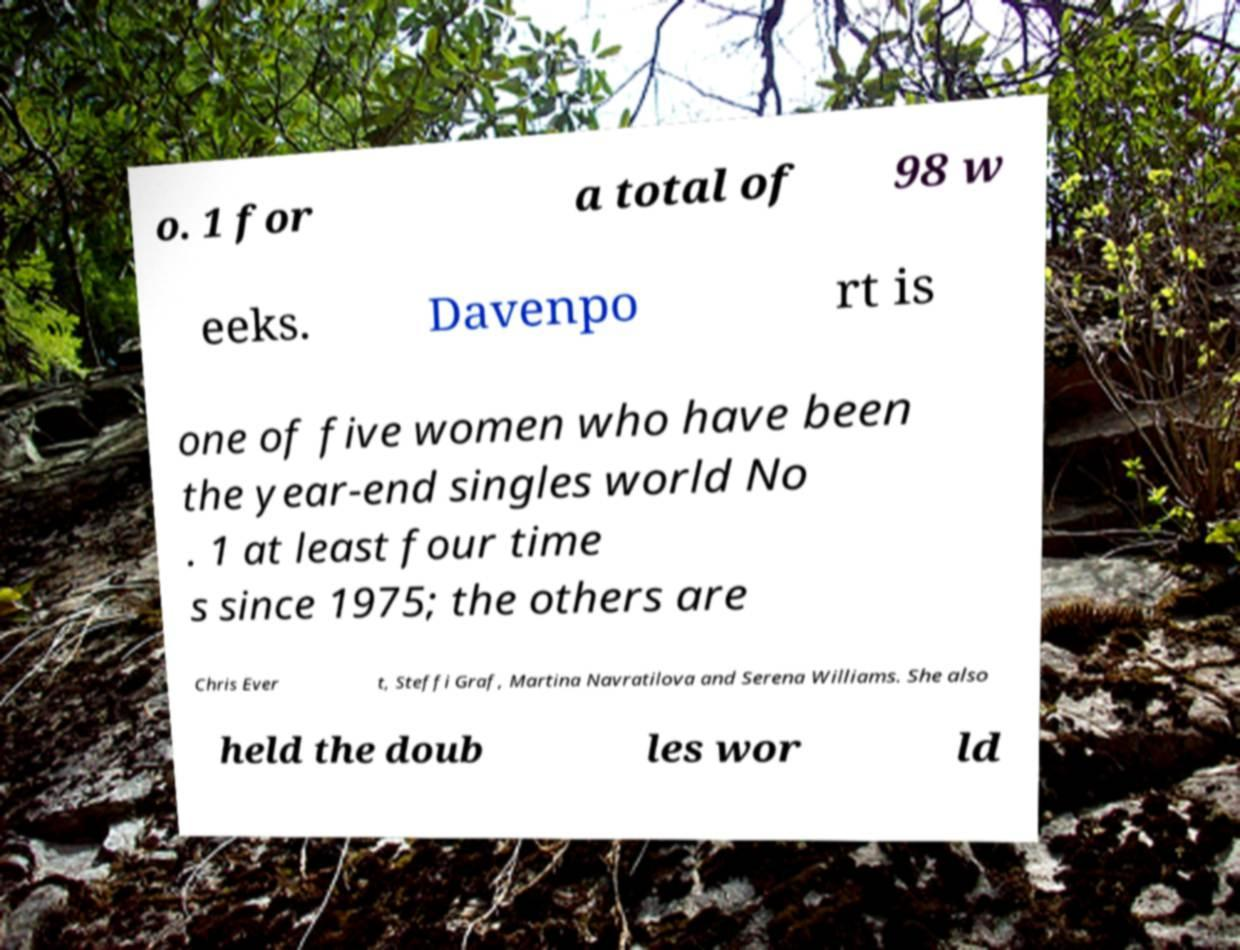There's text embedded in this image that I need extracted. Can you transcribe it verbatim? o. 1 for a total of 98 w eeks. Davenpo rt is one of five women who have been the year-end singles world No . 1 at least four time s since 1975; the others are Chris Ever t, Steffi Graf, Martina Navratilova and Serena Williams. She also held the doub les wor ld 